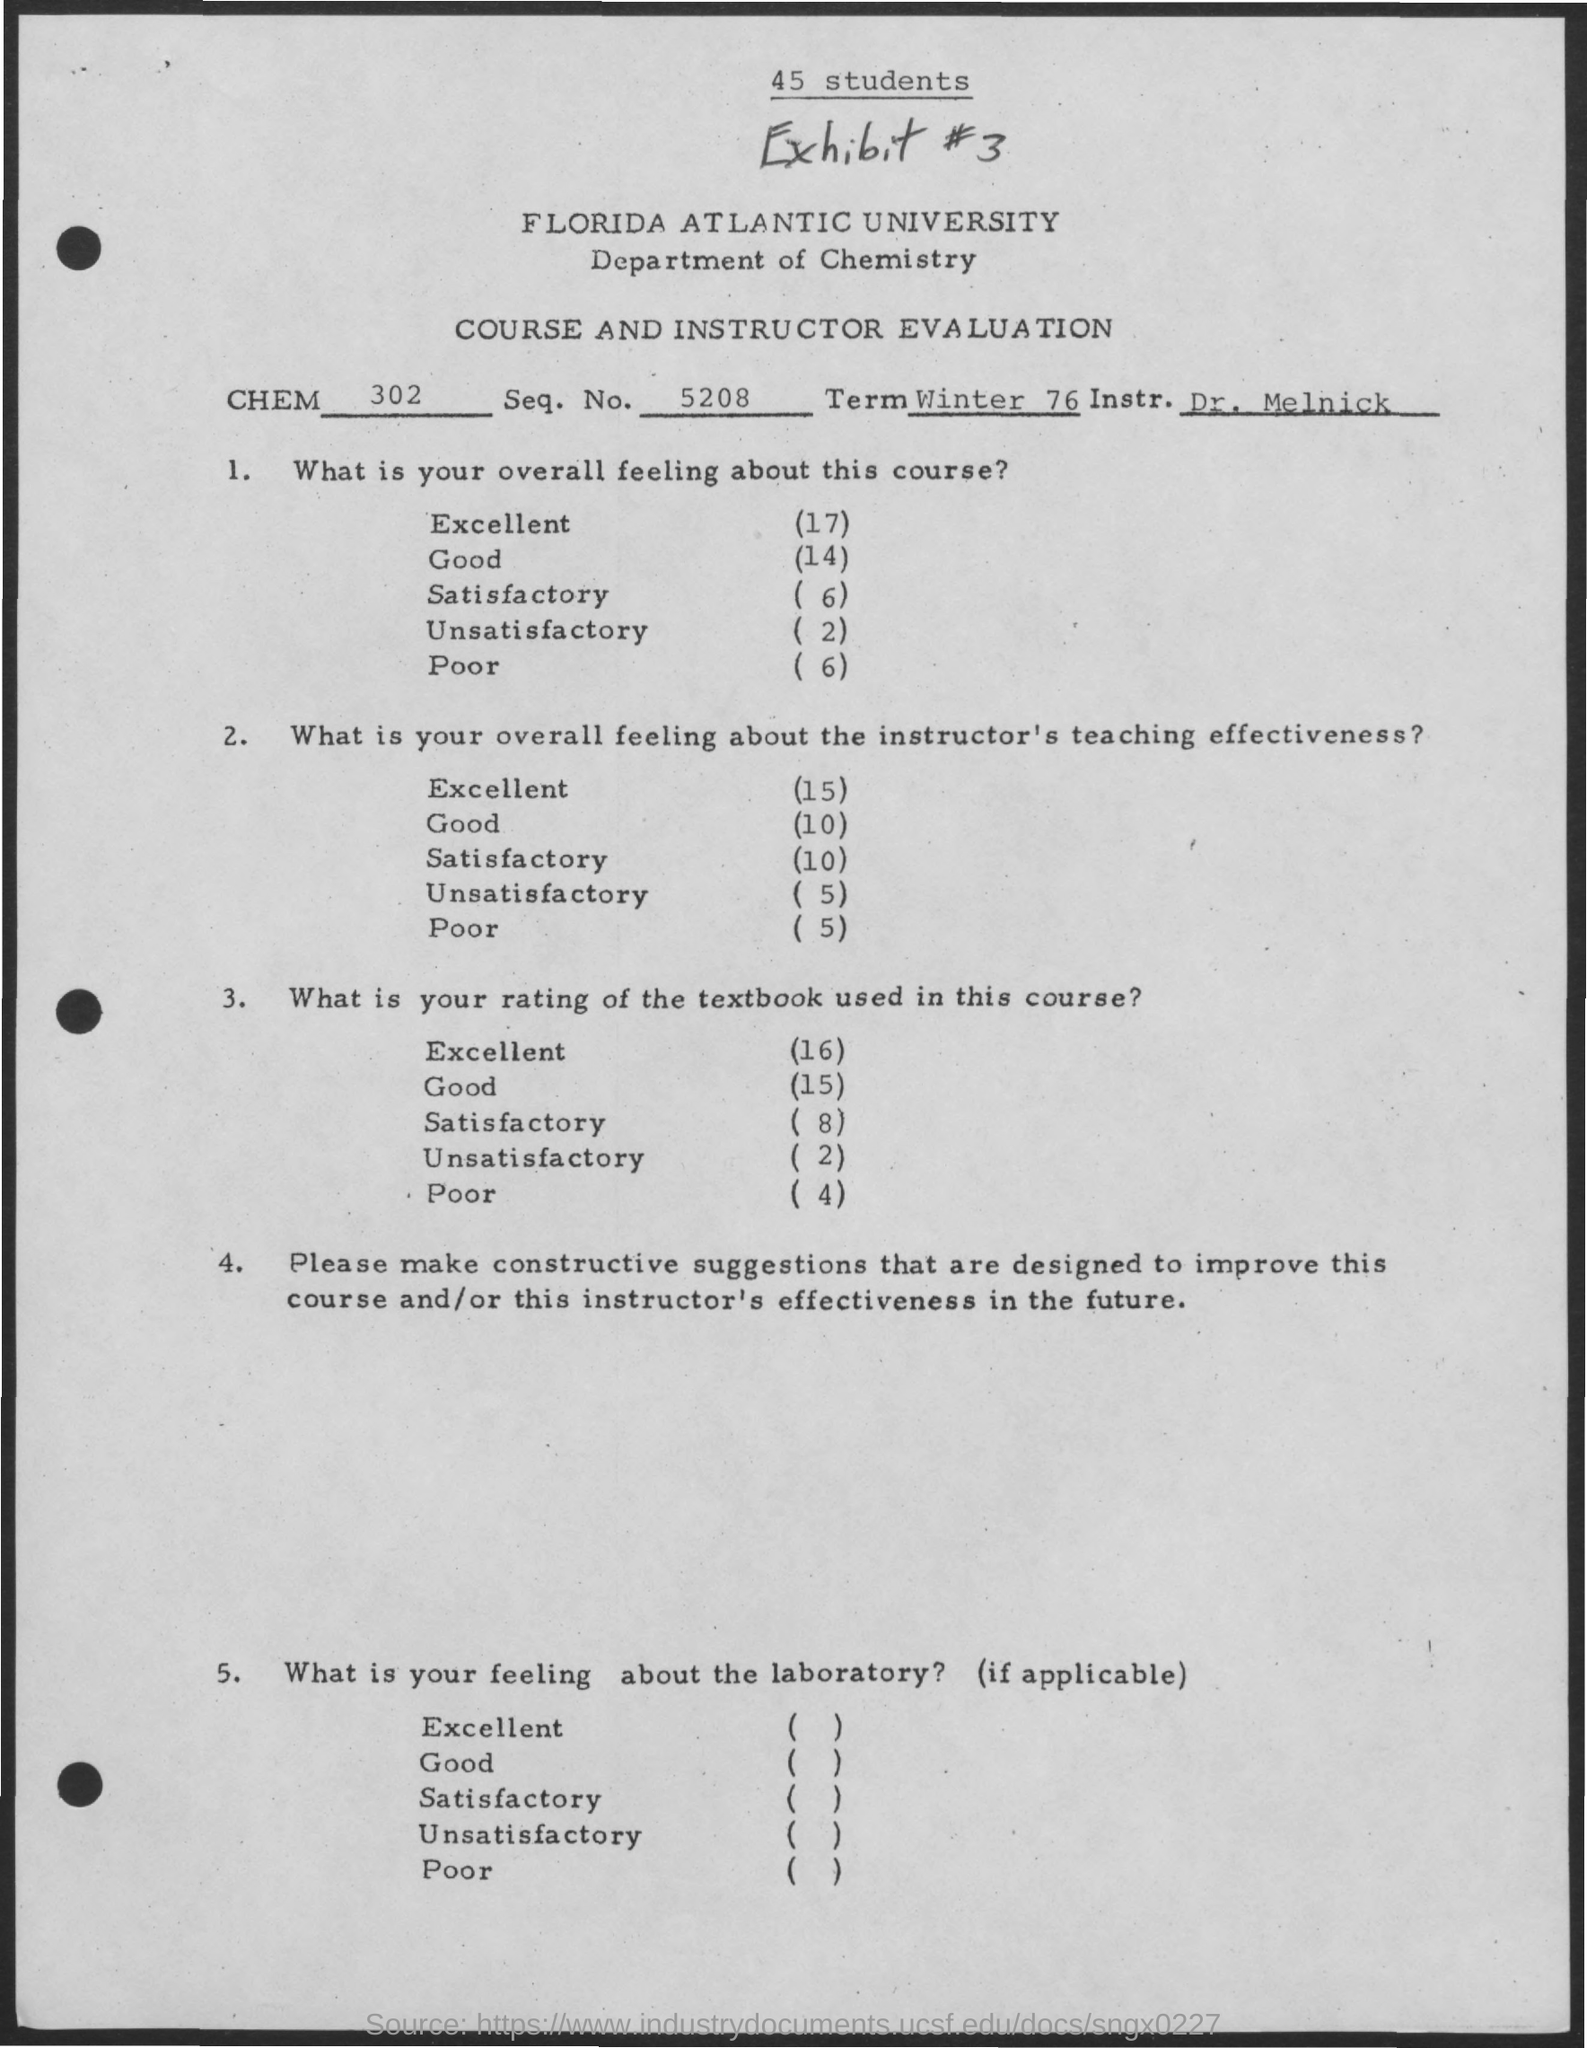What is the Department Name  ?
Keep it short and to the point. Department of Chemistry. What is the Exhibit number ?
Offer a terse response. #3. How many students are there ?
Provide a succinct answer. 45 Students. What is written in the CHEM Field ?
Provide a succinct answer. 302. What is the Seq.No. ?
Provide a succinct answer. 5208. 